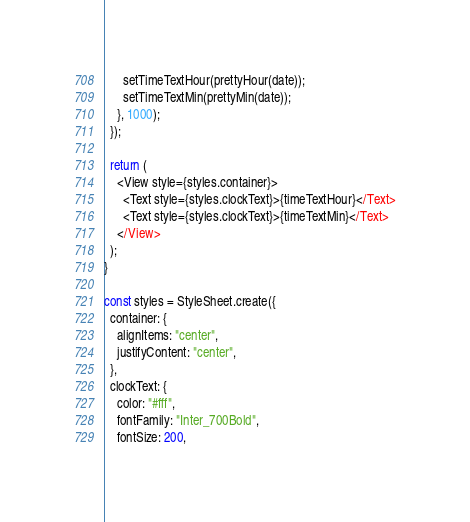Convert code to text. <code><loc_0><loc_0><loc_500><loc_500><_TypeScript_>      setTimeTextHour(prettyHour(date));
      setTimeTextMin(prettyMin(date));
    }, 1000);
  });

  return (
    <View style={styles.container}>
      <Text style={styles.clockText}>{timeTextHour}</Text>
      <Text style={styles.clockText}>{timeTextMin}</Text>
    </View>
  );
}

const styles = StyleSheet.create({
  container: {
    alignItems: "center",
    justifyContent: "center",
  },
  clockText: {
    color: "#fff",
    fontFamily: "Inter_700Bold",
    fontSize: 200,</code> 